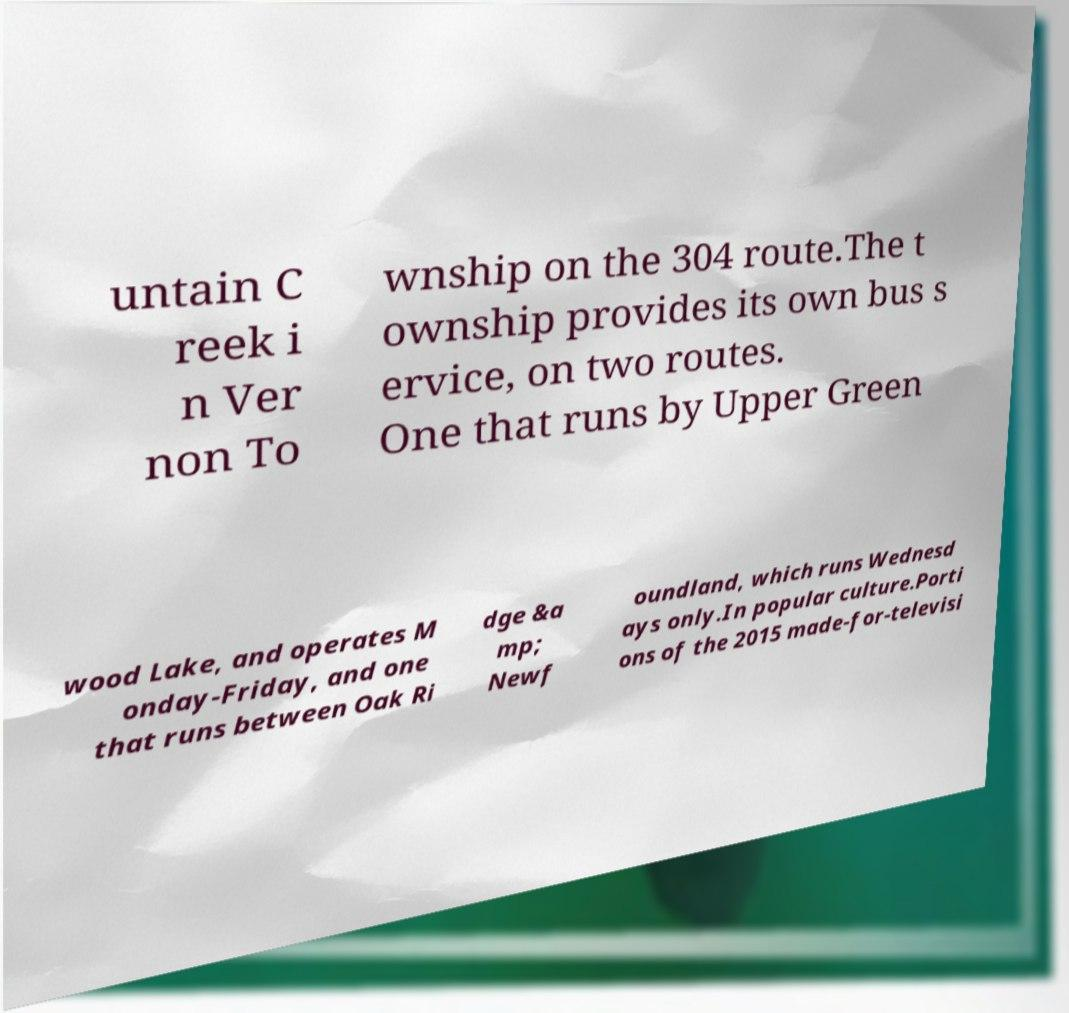What messages or text are displayed in this image? I need them in a readable, typed format. untain C reek i n Ver non To wnship on the 304 route.The t ownship provides its own bus s ervice, on two routes. One that runs by Upper Green wood Lake, and operates M onday-Friday, and one that runs between Oak Ri dge &a mp; Newf oundland, which runs Wednesd ays only.In popular culture.Porti ons of the 2015 made-for-televisi 